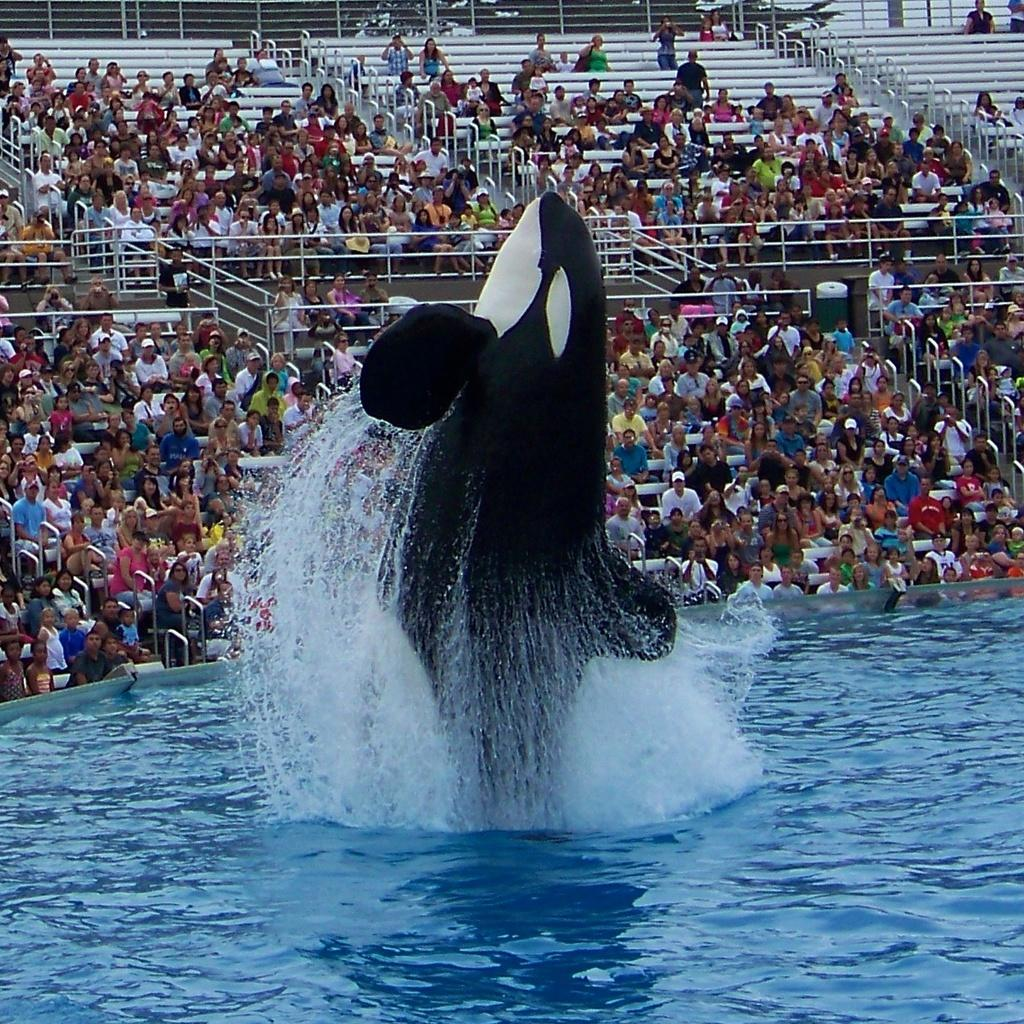What is the main element in the image? There is water in the image. What type of animal can be seen in the water? There is a dolphin in the image. What colors does the dolphin have? The dolphin's color is black and white. What can be seen in the background of the image? There are railings and people sitting in the background of the image. What type of jelly is being used to paint the canvas in the image? There is no canvas or jelly present in the image. 